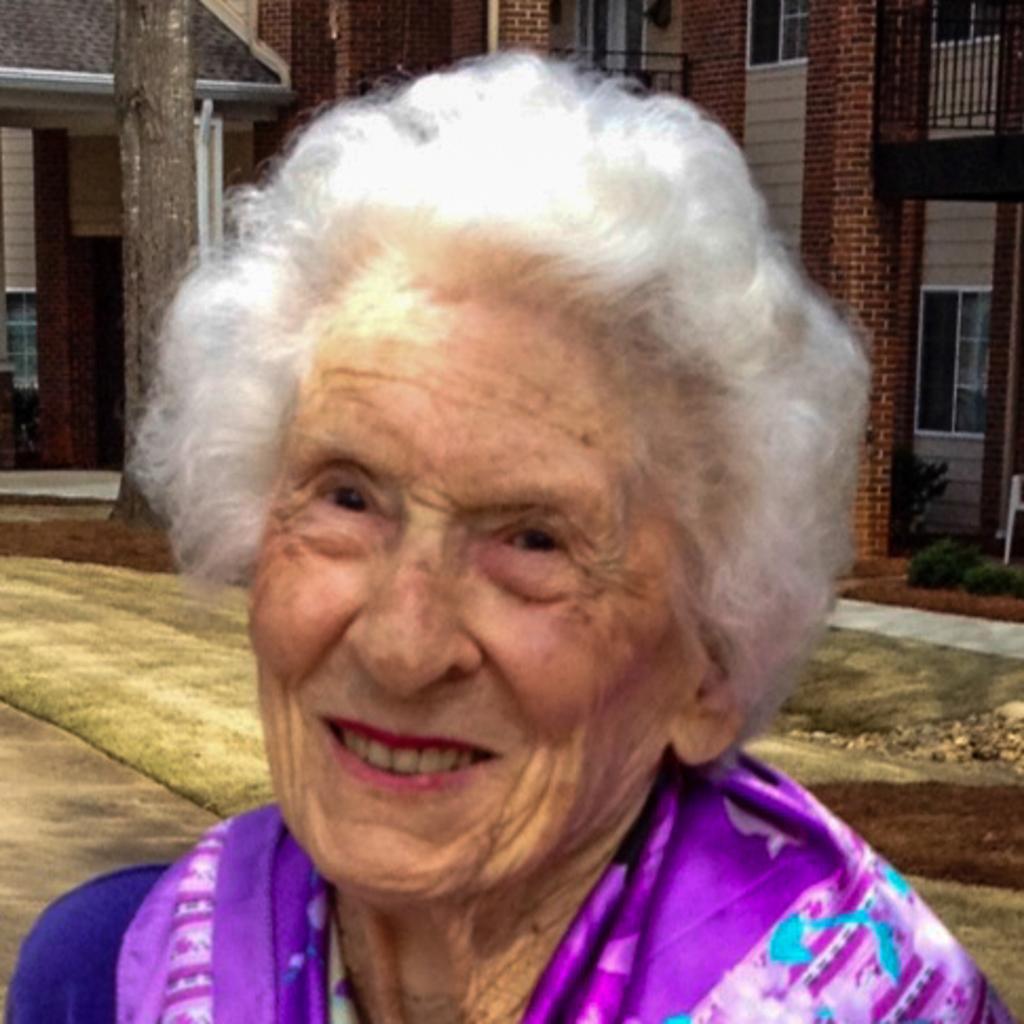How would you summarize this image in a sentence or two? In this image I can see the person and the person is wearing blue and purple color dress. Background I can see few buildings in brown and cream color. 